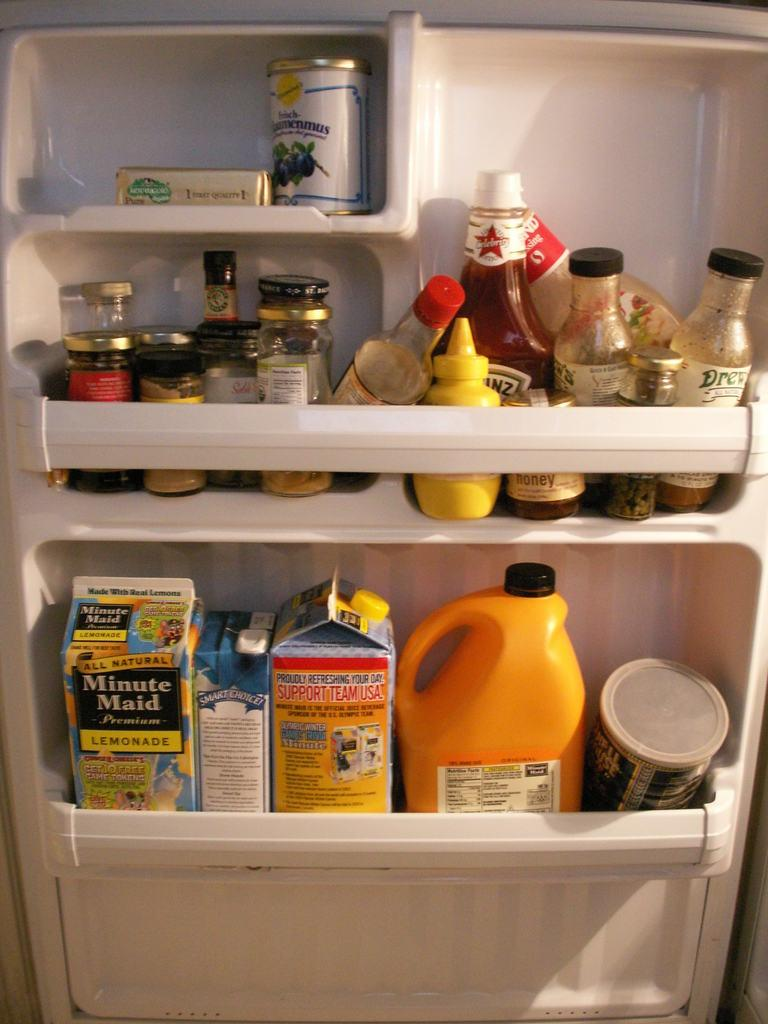<image>
Present a compact description of the photo's key features. Minute Maid orange juice and other drinks and condiments sit on the door of a refrigerator. 